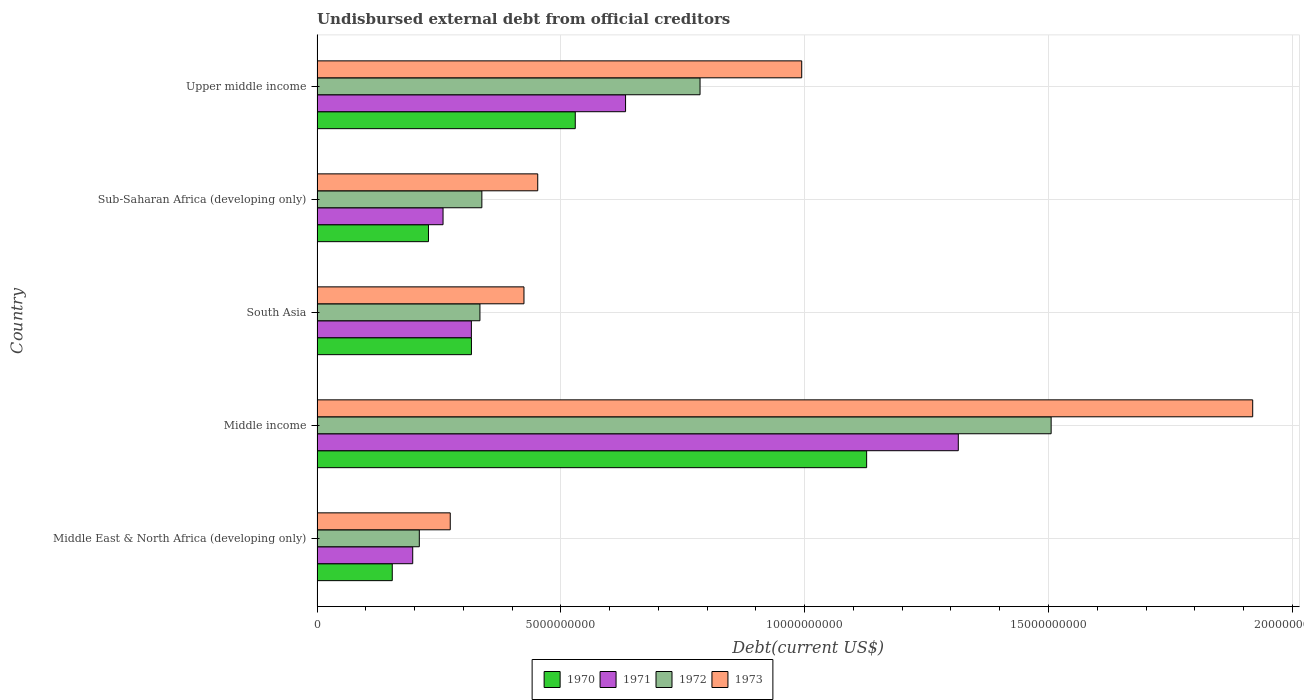How many groups of bars are there?
Provide a short and direct response. 5. Are the number of bars per tick equal to the number of legend labels?
Your answer should be compact. Yes. Are the number of bars on each tick of the Y-axis equal?
Your answer should be very brief. Yes. What is the label of the 3rd group of bars from the top?
Keep it short and to the point. South Asia. What is the total debt in 1973 in Sub-Saharan Africa (developing only)?
Ensure brevity in your answer.  4.53e+09. Across all countries, what is the maximum total debt in 1972?
Give a very brief answer. 1.51e+1. Across all countries, what is the minimum total debt in 1970?
Your answer should be compact. 1.54e+09. In which country was the total debt in 1973 minimum?
Make the answer very short. Middle East & North Africa (developing only). What is the total total debt in 1973 in the graph?
Ensure brevity in your answer.  4.06e+1. What is the difference between the total debt in 1970 in South Asia and that in Upper middle income?
Offer a very short reply. -2.13e+09. What is the difference between the total debt in 1970 in South Asia and the total debt in 1973 in Middle East & North Africa (developing only)?
Keep it short and to the point. 4.35e+08. What is the average total debt in 1972 per country?
Offer a very short reply. 6.35e+09. What is the difference between the total debt in 1972 and total debt in 1971 in Sub-Saharan Africa (developing only)?
Provide a succinct answer. 7.96e+08. In how many countries, is the total debt in 1970 greater than 5000000000 US$?
Make the answer very short. 2. What is the ratio of the total debt in 1970 in Middle East & North Africa (developing only) to that in South Asia?
Keep it short and to the point. 0.49. Is the total debt in 1973 in South Asia less than that in Sub-Saharan Africa (developing only)?
Provide a short and direct response. Yes. What is the difference between the highest and the second highest total debt in 1971?
Make the answer very short. 6.82e+09. What is the difference between the highest and the lowest total debt in 1973?
Ensure brevity in your answer.  1.65e+1. In how many countries, is the total debt in 1970 greater than the average total debt in 1970 taken over all countries?
Your answer should be very brief. 2. What does the 4th bar from the top in Middle income represents?
Provide a succinct answer. 1970. What does the 3rd bar from the bottom in Upper middle income represents?
Offer a terse response. 1972. Are all the bars in the graph horizontal?
Offer a terse response. Yes. What is the difference between two consecutive major ticks on the X-axis?
Give a very brief answer. 5.00e+09. Are the values on the major ticks of X-axis written in scientific E-notation?
Give a very brief answer. No. Does the graph contain any zero values?
Your response must be concise. No. Does the graph contain grids?
Your response must be concise. Yes. Where does the legend appear in the graph?
Your answer should be compact. Bottom center. How many legend labels are there?
Ensure brevity in your answer.  4. What is the title of the graph?
Ensure brevity in your answer.  Undisbursed external debt from official creditors. What is the label or title of the X-axis?
Provide a short and direct response. Debt(current US$). What is the Debt(current US$) in 1970 in Middle East & North Africa (developing only)?
Offer a very short reply. 1.54e+09. What is the Debt(current US$) in 1971 in Middle East & North Africa (developing only)?
Provide a short and direct response. 1.96e+09. What is the Debt(current US$) in 1972 in Middle East & North Africa (developing only)?
Your answer should be very brief. 2.10e+09. What is the Debt(current US$) in 1973 in Middle East & North Africa (developing only)?
Your answer should be compact. 2.73e+09. What is the Debt(current US$) of 1970 in Middle income?
Offer a very short reply. 1.13e+1. What is the Debt(current US$) in 1971 in Middle income?
Keep it short and to the point. 1.32e+1. What is the Debt(current US$) of 1972 in Middle income?
Provide a succinct answer. 1.51e+1. What is the Debt(current US$) of 1973 in Middle income?
Your answer should be compact. 1.92e+1. What is the Debt(current US$) in 1970 in South Asia?
Provide a short and direct response. 3.17e+09. What is the Debt(current US$) of 1971 in South Asia?
Your answer should be very brief. 3.16e+09. What is the Debt(current US$) of 1972 in South Asia?
Keep it short and to the point. 3.34e+09. What is the Debt(current US$) of 1973 in South Asia?
Your response must be concise. 4.24e+09. What is the Debt(current US$) in 1970 in Sub-Saharan Africa (developing only)?
Give a very brief answer. 2.28e+09. What is the Debt(current US$) in 1971 in Sub-Saharan Africa (developing only)?
Your response must be concise. 2.58e+09. What is the Debt(current US$) of 1972 in Sub-Saharan Africa (developing only)?
Provide a succinct answer. 3.38e+09. What is the Debt(current US$) of 1973 in Sub-Saharan Africa (developing only)?
Provide a succinct answer. 4.53e+09. What is the Debt(current US$) of 1970 in Upper middle income?
Ensure brevity in your answer.  5.30e+09. What is the Debt(current US$) of 1971 in Upper middle income?
Provide a short and direct response. 6.33e+09. What is the Debt(current US$) of 1972 in Upper middle income?
Your answer should be very brief. 7.85e+09. What is the Debt(current US$) in 1973 in Upper middle income?
Your response must be concise. 9.94e+09. Across all countries, what is the maximum Debt(current US$) in 1970?
Your answer should be very brief. 1.13e+1. Across all countries, what is the maximum Debt(current US$) in 1971?
Your answer should be compact. 1.32e+1. Across all countries, what is the maximum Debt(current US$) in 1972?
Keep it short and to the point. 1.51e+1. Across all countries, what is the maximum Debt(current US$) of 1973?
Your answer should be very brief. 1.92e+1. Across all countries, what is the minimum Debt(current US$) in 1970?
Offer a terse response. 1.54e+09. Across all countries, what is the minimum Debt(current US$) in 1971?
Provide a succinct answer. 1.96e+09. Across all countries, what is the minimum Debt(current US$) in 1972?
Offer a very short reply. 2.10e+09. Across all countries, what is the minimum Debt(current US$) in 1973?
Give a very brief answer. 2.73e+09. What is the total Debt(current US$) in 1970 in the graph?
Offer a terse response. 2.36e+1. What is the total Debt(current US$) of 1971 in the graph?
Your answer should be very brief. 2.72e+1. What is the total Debt(current US$) in 1972 in the graph?
Offer a very short reply. 3.17e+1. What is the total Debt(current US$) in 1973 in the graph?
Provide a short and direct response. 4.06e+1. What is the difference between the Debt(current US$) of 1970 in Middle East & North Africa (developing only) and that in Middle income?
Provide a short and direct response. -9.73e+09. What is the difference between the Debt(current US$) in 1971 in Middle East & North Africa (developing only) and that in Middle income?
Your answer should be very brief. -1.12e+1. What is the difference between the Debt(current US$) of 1972 in Middle East & North Africa (developing only) and that in Middle income?
Your answer should be compact. -1.30e+1. What is the difference between the Debt(current US$) in 1973 in Middle East & North Africa (developing only) and that in Middle income?
Your response must be concise. -1.65e+1. What is the difference between the Debt(current US$) of 1970 in Middle East & North Africa (developing only) and that in South Asia?
Provide a short and direct response. -1.62e+09. What is the difference between the Debt(current US$) in 1971 in Middle East & North Africa (developing only) and that in South Asia?
Offer a very short reply. -1.20e+09. What is the difference between the Debt(current US$) of 1972 in Middle East & North Africa (developing only) and that in South Asia?
Ensure brevity in your answer.  -1.24e+09. What is the difference between the Debt(current US$) in 1973 in Middle East & North Africa (developing only) and that in South Asia?
Keep it short and to the point. -1.51e+09. What is the difference between the Debt(current US$) of 1970 in Middle East & North Africa (developing only) and that in Sub-Saharan Africa (developing only)?
Keep it short and to the point. -7.42e+08. What is the difference between the Debt(current US$) in 1971 in Middle East & North Africa (developing only) and that in Sub-Saharan Africa (developing only)?
Keep it short and to the point. -6.22e+08. What is the difference between the Debt(current US$) of 1972 in Middle East & North Africa (developing only) and that in Sub-Saharan Africa (developing only)?
Your response must be concise. -1.28e+09. What is the difference between the Debt(current US$) in 1973 in Middle East & North Africa (developing only) and that in Sub-Saharan Africa (developing only)?
Make the answer very short. -1.79e+09. What is the difference between the Debt(current US$) of 1970 in Middle East & North Africa (developing only) and that in Upper middle income?
Offer a terse response. -3.75e+09. What is the difference between the Debt(current US$) of 1971 in Middle East & North Africa (developing only) and that in Upper middle income?
Ensure brevity in your answer.  -4.36e+09. What is the difference between the Debt(current US$) in 1972 in Middle East & North Africa (developing only) and that in Upper middle income?
Offer a very short reply. -5.76e+09. What is the difference between the Debt(current US$) of 1973 in Middle East & North Africa (developing only) and that in Upper middle income?
Provide a succinct answer. -7.21e+09. What is the difference between the Debt(current US$) of 1970 in Middle income and that in South Asia?
Provide a succinct answer. 8.10e+09. What is the difference between the Debt(current US$) in 1971 in Middle income and that in South Asia?
Keep it short and to the point. 9.99e+09. What is the difference between the Debt(current US$) of 1972 in Middle income and that in South Asia?
Ensure brevity in your answer.  1.17e+1. What is the difference between the Debt(current US$) in 1973 in Middle income and that in South Asia?
Give a very brief answer. 1.49e+1. What is the difference between the Debt(current US$) of 1970 in Middle income and that in Sub-Saharan Africa (developing only)?
Keep it short and to the point. 8.99e+09. What is the difference between the Debt(current US$) in 1971 in Middle income and that in Sub-Saharan Africa (developing only)?
Ensure brevity in your answer.  1.06e+1. What is the difference between the Debt(current US$) of 1972 in Middle income and that in Sub-Saharan Africa (developing only)?
Provide a short and direct response. 1.17e+1. What is the difference between the Debt(current US$) in 1973 in Middle income and that in Sub-Saharan Africa (developing only)?
Your answer should be compact. 1.47e+1. What is the difference between the Debt(current US$) of 1970 in Middle income and that in Upper middle income?
Offer a very short reply. 5.98e+09. What is the difference between the Debt(current US$) of 1971 in Middle income and that in Upper middle income?
Give a very brief answer. 6.82e+09. What is the difference between the Debt(current US$) of 1972 in Middle income and that in Upper middle income?
Offer a terse response. 7.20e+09. What is the difference between the Debt(current US$) in 1973 in Middle income and that in Upper middle income?
Provide a succinct answer. 9.25e+09. What is the difference between the Debt(current US$) in 1970 in South Asia and that in Sub-Saharan Africa (developing only)?
Your answer should be very brief. 8.81e+08. What is the difference between the Debt(current US$) in 1971 in South Asia and that in Sub-Saharan Africa (developing only)?
Offer a very short reply. 5.81e+08. What is the difference between the Debt(current US$) of 1972 in South Asia and that in Sub-Saharan Africa (developing only)?
Your answer should be compact. -3.94e+07. What is the difference between the Debt(current US$) of 1973 in South Asia and that in Sub-Saharan Africa (developing only)?
Your answer should be very brief. -2.82e+08. What is the difference between the Debt(current US$) of 1970 in South Asia and that in Upper middle income?
Offer a terse response. -2.13e+09. What is the difference between the Debt(current US$) in 1971 in South Asia and that in Upper middle income?
Give a very brief answer. -3.16e+09. What is the difference between the Debt(current US$) of 1972 in South Asia and that in Upper middle income?
Offer a very short reply. -4.51e+09. What is the difference between the Debt(current US$) of 1973 in South Asia and that in Upper middle income?
Offer a very short reply. -5.70e+09. What is the difference between the Debt(current US$) of 1970 in Sub-Saharan Africa (developing only) and that in Upper middle income?
Offer a terse response. -3.01e+09. What is the difference between the Debt(current US$) in 1971 in Sub-Saharan Africa (developing only) and that in Upper middle income?
Your answer should be compact. -3.74e+09. What is the difference between the Debt(current US$) in 1972 in Sub-Saharan Africa (developing only) and that in Upper middle income?
Make the answer very short. -4.47e+09. What is the difference between the Debt(current US$) of 1973 in Sub-Saharan Africa (developing only) and that in Upper middle income?
Your answer should be very brief. -5.41e+09. What is the difference between the Debt(current US$) of 1970 in Middle East & North Africa (developing only) and the Debt(current US$) of 1971 in Middle income?
Provide a short and direct response. -1.16e+1. What is the difference between the Debt(current US$) of 1970 in Middle East & North Africa (developing only) and the Debt(current US$) of 1972 in Middle income?
Give a very brief answer. -1.35e+1. What is the difference between the Debt(current US$) in 1970 in Middle East & North Africa (developing only) and the Debt(current US$) in 1973 in Middle income?
Make the answer very short. -1.76e+1. What is the difference between the Debt(current US$) in 1971 in Middle East & North Africa (developing only) and the Debt(current US$) in 1972 in Middle income?
Give a very brief answer. -1.31e+1. What is the difference between the Debt(current US$) in 1971 in Middle East & North Africa (developing only) and the Debt(current US$) in 1973 in Middle income?
Provide a succinct answer. -1.72e+1. What is the difference between the Debt(current US$) of 1972 in Middle East & North Africa (developing only) and the Debt(current US$) of 1973 in Middle income?
Make the answer very short. -1.71e+1. What is the difference between the Debt(current US$) in 1970 in Middle East & North Africa (developing only) and the Debt(current US$) in 1971 in South Asia?
Your response must be concise. -1.62e+09. What is the difference between the Debt(current US$) of 1970 in Middle East & North Africa (developing only) and the Debt(current US$) of 1972 in South Asia?
Keep it short and to the point. -1.80e+09. What is the difference between the Debt(current US$) of 1970 in Middle East & North Africa (developing only) and the Debt(current US$) of 1973 in South Asia?
Make the answer very short. -2.70e+09. What is the difference between the Debt(current US$) of 1971 in Middle East & North Africa (developing only) and the Debt(current US$) of 1972 in South Asia?
Ensure brevity in your answer.  -1.38e+09. What is the difference between the Debt(current US$) in 1971 in Middle East & North Africa (developing only) and the Debt(current US$) in 1973 in South Asia?
Ensure brevity in your answer.  -2.28e+09. What is the difference between the Debt(current US$) in 1972 in Middle East & North Africa (developing only) and the Debt(current US$) in 1973 in South Asia?
Ensure brevity in your answer.  -2.15e+09. What is the difference between the Debt(current US$) in 1970 in Middle East & North Africa (developing only) and the Debt(current US$) in 1971 in Sub-Saharan Africa (developing only)?
Ensure brevity in your answer.  -1.04e+09. What is the difference between the Debt(current US$) of 1970 in Middle East & North Africa (developing only) and the Debt(current US$) of 1972 in Sub-Saharan Africa (developing only)?
Provide a short and direct response. -1.84e+09. What is the difference between the Debt(current US$) of 1970 in Middle East & North Africa (developing only) and the Debt(current US$) of 1973 in Sub-Saharan Africa (developing only)?
Your response must be concise. -2.98e+09. What is the difference between the Debt(current US$) of 1971 in Middle East & North Africa (developing only) and the Debt(current US$) of 1972 in Sub-Saharan Africa (developing only)?
Ensure brevity in your answer.  -1.42e+09. What is the difference between the Debt(current US$) of 1971 in Middle East & North Africa (developing only) and the Debt(current US$) of 1973 in Sub-Saharan Africa (developing only)?
Ensure brevity in your answer.  -2.56e+09. What is the difference between the Debt(current US$) in 1972 in Middle East & North Africa (developing only) and the Debt(current US$) in 1973 in Sub-Saharan Africa (developing only)?
Give a very brief answer. -2.43e+09. What is the difference between the Debt(current US$) in 1970 in Middle East & North Africa (developing only) and the Debt(current US$) in 1971 in Upper middle income?
Give a very brief answer. -4.78e+09. What is the difference between the Debt(current US$) of 1970 in Middle East & North Africa (developing only) and the Debt(current US$) of 1972 in Upper middle income?
Make the answer very short. -6.31e+09. What is the difference between the Debt(current US$) of 1970 in Middle East & North Africa (developing only) and the Debt(current US$) of 1973 in Upper middle income?
Your response must be concise. -8.40e+09. What is the difference between the Debt(current US$) of 1971 in Middle East & North Africa (developing only) and the Debt(current US$) of 1972 in Upper middle income?
Give a very brief answer. -5.89e+09. What is the difference between the Debt(current US$) of 1971 in Middle East & North Africa (developing only) and the Debt(current US$) of 1973 in Upper middle income?
Provide a short and direct response. -7.98e+09. What is the difference between the Debt(current US$) of 1972 in Middle East & North Africa (developing only) and the Debt(current US$) of 1973 in Upper middle income?
Make the answer very short. -7.84e+09. What is the difference between the Debt(current US$) of 1970 in Middle income and the Debt(current US$) of 1971 in South Asia?
Give a very brief answer. 8.11e+09. What is the difference between the Debt(current US$) of 1970 in Middle income and the Debt(current US$) of 1972 in South Asia?
Your answer should be very brief. 7.93e+09. What is the difference between the Debt(current US$) in 1970 in Middle income and the Debt(current US$) in 1973 in South Asia?
Give a very brief answer. 7.03e+09. What is the difference between the Debt(current US$) in 1971 in Middle income and the Debt(current US$) in 1972 in South Asia?
Give a very brief answer. 9.81e+09. What is the difference between the Debt(current US$) of 1971 in Middle income and the Debt(current US$) of 1973 in South Asia?
Offer a terse response. 8.91e+09. What is the difference between the Debt(current US$) of 1972 in Middle income and the Debt(current US$) of 1973 in South Asia?
Provide a succinct answer. 1.08e+1. What is the difference between the Debt(current US$) of 1970 in Middle income and the Debt(current US$) of 1971 in Sub-Saharan Africa (developing only)?
Offer a terse response. 8.69e+09. What is the difference between the Debt(current US$) of 1970 in Middle income and the Debt(current US$) of 1972 in Sub-Saharan Africa (developing only)?
Provide a short and direct response. 7.89e+09. What is the difference between the Debt(current US$) in 1970 in Middle income and the Debt(current US$) in 1973 in Sub-Saharan Africa (developing only)?
Make the answer very short. 6.75e+09. What is the difference between the Debt(current US$) of 1971 in Middle income and the Debt(current US$) of 1972 in Sub-Saharan Africa (developing only)?
Your answer should be very brief. 9.77e+09. What is the difference between the Debt(current US$) in 1971 in Middle income and the Debt(current US$) in 1973 in Sub-Saharan Africa (developing only)?
Make the answer very short. 8.62e+09. What is the difference between the Debt(current US$) of 1972 in Middle income and the Debt(current US$) of 1973 in Sub-Saharan Africa (developing only)?
Ensure brevity in your answer.  1.05e+1. What is the difference between the Debt(current US$) in 1970 in Middle income and the Debt(current US$) in 1971 in Upper middle income?
Ensure brevity in your answer.  4.94e+09. What is the difference between the Debt(current US$) of 1970 in Middle income and the Debt(current US$) of 1972 in Upper middle income?
Offer a terse response. 3.42e+09. What is the difference between the Debt(current US$) of 1970 in Middle income and the Debt(current US$) of 1973 in Upper middle income?
Ensure brevity in your answer.  1.33e+09. What is the difference between the Debt(current US$) of 1971 in Middle income and the Debt(current US$) of 1972 in Upper middle income?
Provide a short and direct response. 5.30e+09. What is the difference between the Debt(current US$) in 1971 in Middle income and the Debt(current US$) in 1973 in Upper middle income?
Keep it short and to the point. 3.21e+09. What is the difference between the Debt(current US$) of 1972 in Middle income and the Debt(current US$) of 1973 in Upper middle income?
Offer a very short reply. 5.12e+09. What is the difference between the Debt(current US$) in 1970 in South Asia and the Debt(current US$) in 1971 in Sub-Saharan Africa (developing only)?
Make the answer very short. 5.82e+08. What is the difference between the Debt(current US$) of 1970 in South Asia and the Debt(current US$) of 1972 in Sub-Saharan Africa (developing only)?
Your response must be concise. -2.14e+08. What is the difference between the Debt(current US$) of 1970 in South Asia and the Debt(current US$) of 1973 in Sub-Saharan Africa (developing only)?
Offer a very short reply. -1.36e+09. What is the difference between the Debt(current US$) of 1971 in South Asia and the Debt(current US$) of 1972 in Sub-Saharan Africa (developing only)?
Provide a succinct answer. -2.15e+08. What is the difference between the Debt(current US$) of 1971 in South Asia and the Debt(current US$) of 1973 in Sub-Saharan Africa (developing only)?
Your answer should be compact. -1.36e+09. What is the difference between the Debt(current US$) of 1972 in South Asia and the Debt(current US$) of 1973 in Sub-Saharan Africa (developing only)?
Provide a succinct answer. -1.19e+09. What is the difference between the Debt(current US$) of 1970 in South Asia and the Debt(current US$) of 1971 in Upper middle income?
Make the answer very short. -3.16e+09. What is the difference between the Debt(current US$) in 1970 in South Asia and the Debt(current US$) in 1972 in Upper middle income?
Give a very brief answer. -4.69e+09. What is the difference between the Debt(current US$) in 1970 in South Asia and the Debt(current US$) in 1973 in Upper middle income?
Offer a very short reply. -6.77e+09. What is the difference between the Debt(current US$) of 1971 in South Asia and the Debt(current US$) of 1972 in Upper middle income?
Give a very brief answer. -4.69e+09. What is the difference between the Debt(current US$) of 1971 in South Asia and the Debt(current US$) of 1973 in Upper middle income?
Provide a short and direct response. -6.77e+09. What is the difference between the Debt(current US$) of 1972 in South Asia and the Debt(current US$) of 1973 in Upper middle income?
Your answer should be compact. -6.60e+09. What is the difference between the Debt(current US$) of 1970 in Sub-Saharan Africa (developing only) and the Debt(current US$) of 1971 in Upper middle income?
Your answer should be very brief. -4.04e+09. What is the difference between the Debt(current US$) in 1970 in Sub-Saharan Africa (developing only) and the Debt(current US$) in 1972 in Upper middle income?
Your answer should be compact. -5.57e+09. What is the difference between the Debt(current US$) of 1970 in Sub-Saharan Africa (developing only) and the Debt(current US$) of 1973 in Upper middle income?
Offer a very short reply. -7.65e+09. What is the difference between the Debt(current US$) in 1971 in Sub-Saharan Africa (developing only) and the Debt(current US$) in 1972 in Upper middle income?
Provide a short and direct response. -5.27e+09. What is the difference between the Debt(current US$) in 1971 in Sub-Saharan Africa (developing only) and the Debt(current US$) in 1973 in Upper middle income?
Offer a very short reply. -7.36e+09. What is the difference between the Debt(current US$) in 1972 in Sub-Saharan Africa (developing only) and the Debt(current US$) in 1973 in Upper middle income?
Offer a very short reply. -6.56e+09. What is the average Debt(current US$) in 1970 per country?
Provide a short and direct response. 4.71e+09. What is the average Debt(current US$) in 1971 per country?
Give a very brief answer. 5.44e+09. What is the average Debt(current US$) in 1972 per country?
Make the answer very short. 6.35e+09. What is the average Debt(current US$) in 1973 per country?
Your answer should be compact. 8.13e+09. What is the difference between the Debt(current US$) in 1970 and Debt(current US$) in 1971 in Middle East & North Africa (developing only)?
Your answer should be compact. -4.19e+08. What is the difference between the Debt(current US$) of 1970 and Debt(current US$) of 1972 in Middle East & North Africa (developing only)?
Offer a terse response. -5.55e+08. What is the difference between the Debt(current US$) in 1970 and Debt(current US$) in 1973 in Middle East & North Africa (developing only)?
Provide a succinct answer. -1.19e+09. What is the difference between the Debt(current US$) in 1971 and Debt(current US$) in 1972 in Middle East & North Africa (developing only)?
Your response must be concise. -1.35e+08. What is the difference between the Debt(current US$) of 1971 and Debt(current US$) of 1973 in Middle East & North Africa (developing only)?
Offer a very short reply. -7.70e+08. What is the difference between the Debt(current US$) of 1972 and Debt(current US$) of 1973 in Middle East & North Africa (developing only)?
Offer a very short reply. -6.34e+08. What is the difference between the Debt(current US$) in 1970 and Debt(current US$) in 1971 in Middle income?
Keep it short and to the point. -1.88e+09. What is the difference between the Debt(current US$) of 1970 and Debt(current US$) of 1972 in Middle income?
Your response must be concise. -3.78e+09. What is the difference between the Debt(current US$) in 1970 and Debt(current US$) in 1973 in Middle income?
Ensure brevity in your answer.  -7.92e+09. What is the difference between the Debt(current US$) of 1971 and Debt(current US$) of 1972 in Middle income?
Provide a succinct answer. -1.90e+09. What is the difference between the Debt(current US$) of 1971 and Debt(current US$) of 1973 in Middle income?
Keep it short and to the point. -6.04e+09. What is the difference between the Debt(current US$) of 1972 and Debt(current US$) of 1973 in Middle income?
Make the answer very short. -4.13e+09. What is the difference between the Debt(current US$) in 1970 and Debt(current US$) in 1971 in South Asia?
Offer a very short reply. 1.31e+06. What is the difference between the Debt(current US$) in 1970 and Debt(current US$) in 1972 in South Asia?
Your response must be concise. -1.74e+08. What is the difference between the Debt(current US$) of 1970 and Debt(current US$) of 1973 in South Asia?
Your answer should be compact. -1.08e+09. What is the difference between the Debt(current US$) in 1971 and Debt(current US$) in 1972 in South Asia?
Your answer should be very brief. -1.76e+08. What is the difference between the Debt(current US$) in 1971 and Debt(current US$) in 1973 in South Asia?
Your answer should be very brief. -1.08e+09. What is the difference between the Debt(current US$) of 1972 and Debt(current US$) of 1973 in South Asia?
Your answer should be very brief. -9.03e+08. What is the difference between the Debt(current US$) in 1970 and Debt(current US$) in 1971 in Sub-Saharan Africa (developing only)?
Ensure brevity in your answer.  -2.99e+08. What is the difference between the Debt(current US$) in 1970 and Debt(current US$) in 1972 in Sub-Saharan Africa (developing only)?
Your answer should be compact. -1.09e+09. What is the difference between the Debt(current US$) in 1970 and Debt(current US$) in 1973 in Sub-Saharan Africa (developing only)?
Your response must be concise. -2.24e+09. What is the difference between the Debt(current US$) of 1971 and Debt(current US$) of 1972 in Sub-Saharan Africa (developing only)?
Make the answer very short. -7.96e+08. What is the difference between the Debt(current US$) in 1971 and Debt(current US$) in 1973 in Sub-Saharan Africa (developing only)?
Your answer should be very brief. -1.94e+09. What is the difference between the Debt(current US$) in 1972 and Debt(current US$) in 1973 in Sub-Saharan Africa (developing only)?
Your answer should be very brief. -1.15e+09. What is the difference between the Debt(current US$) in 1970 and Debt(current US$) in 1971 in Upper middle income?
Provide a short and direct response. -1.03e+09. What is the difference between the Debt(current US$) of 1970 and Debt(current US$) of 1972 in Upper middle income?
Give a very brief answer. -2.56e+09. What is the difference between the Debt(current US$) in 1970 and Debt(current US$) in 1973 in Upper middle income?
Keep it short and to the point. -4.64e+09. What is the difference between the Debt(current US$) of 1971 and Debt(current US$) of 1972 in Upper middle income?
Provide a short and direct response. -1.53e+09. What is the difference between the Debt(current US$) in 1971 and Debt(current US$) in 1973 in Upper middle income?
Keep it short and to the point. -3.61e+09. What is the difference between the Debt(current US$) of 1972 and Debt(current US$) of 1973 in Upper middle income?
Ensure brevity in your answer.  -2.08e+09. What is the ratio of the Debt(current US$) of 1970 in Middle East & North Africa (developing only) to that in Middle income?
Your answer should be compact. 0.14. What is the ratio of the Debt(current US$) in 1971 in Middle East & North Africa (developing only) to that in Middle income?
Provide a succinct answer. 0.15. What is the ratio of the Debt(current US$) in 1972 in Middle East & North Africa (developing only) to that in Middle income?
Your response must be concise. 0.14. What is the ratio of the Debt(current US$) of 1973 in Middle East & North Africa (developing only) to that in Middle income?
Provide a succinct answer. 0.14. What is the ratio of the Debt(current US$) in 1970 in Middle East & North Africa (developing only) to that in South Asia?
Offer a very short reply. 0.49. What is the ratio of the Debt(current US$) in 1971 in Middle East & North Africa (developing only) to that in South Asia?
Your answer should be very brief. 0.62. What is the ratio of the Debt(current US$) in 1972 in Middle East & North Africa (developing only) to that in South Asia?
Offer a terse response. 0.63. What is the ratio of the Debt(current US$) in 1973 in Middle East & North Africa (developing only) to that in South Asia?
Offer a terse response. 0.64. What is the ratio of the Debt(current US$) of 1970 in Middle East & North Africa (developing only) to that in Sub-Saharan Africa (developing only)?
Ensure brevity in your answer.  0.68. What is the ratio of the Debt(current US$) of 1971 in Middle East & North Africa (developing only) to that in Sub-Saharan Africa (developing only)?
Ensure brevity in your answer.  0.76. What is the ratio of the Debt(current US$) of 1972 in Middle East & North Africa (developing only) to that in Sub-Saharan Africa (developing only)?
Your response must be concise. 0.62. What is the ratio of the Debt(current US$) in 1973 in Middle East & North Africa (developing only) to that in Sub-Saharan Africa (developing only)?
Your answer should be compact. 0.6. What is the ratio of the Debt(current US$) of 1970 in Middle East & North Africa (developing only) to that in Upper middle income?
Offer a very short reply. 0.29. What is the ratio of the Debt(current US$) in 1971 in Middle East & North Africa (developing only) to that in Upper middle income?
Ensure brevity in your answer.  0.31. What is the ratio of the Debt(current US$) in 1972 in Middle East & North Africa (developing only) to that in Upper middle income?
Offer a very short reply. 0.27. What is the ratio of the Debt(current US$) of 1973 in Middle East & North Africa (developing only) to that in Upper middle income?
Give a very brief answer. 0.27. What is the ratio of the Debt(current US$) in 1970 in Middle income to that in South Asia?
Ensure brevity in your answer.  3.56. What is the ratio of the Debt(current US$) in 1971 in Middle income to that in South Asia?
Your response must be concise. 4.16. What is the ratio of the Debt(current US$) in 1972 in Middle income to that in South Asia?
Ensure brevity in your answer.  4.51. What is the ratio of the Debt(current US$) in 1973 in Middle income to that in South Asia?
Offer a terse response. 4.52. What is the ratio of the Debt(current US$) of 1970 in Middle income to that in Sub-Saharan Africa (developing only)?
Provide a short and direct response. 4.93. What is the ratio of the Debt(current US$) of 1971 in Middle income to that in Sub-Saharan Africa (developing only)?
Your answer should be compact. 5.09. What is the ratio of the Debt(current US$) in 1972 in Middle income to that in Sub-Saharan Africa (developing only)?
Give a very brief answer. 4.45. What is the ratio of the Debt(current US$) in 1973 in Middle income to that in Sub-Saharan Africa (developing only)?
Your answer should be compact. 4.24. What is the ratio of the Debt(current US$) in 1970 in Middle income to that in Upper middle income?
Offer a terse response. 2.13. What is the ratio of the Debt(current US$) in 1971 in Middle income to that in Upper middle income?
Keep it short and to the point. 2.08. What is the ratio of the Debt(current US$) of 1972 in Middle income to that in Upper middle income?
Offer a terse response. 1.92. What is the ratio of the Debt(current US$) in 1973 in Middle income to that in Upper middle income?
Keep it short and to the point. 1.93. What is the ratio of the Debt(current US$) in 1970 in South Asia to that in Sub-Saharan Africa (developing only)?
Give a very brief answer. 1.39. What is the ratio of the Debt(current US$) in 1971 in South Asia to that in Sub-Saharan Africa (developing only)?
Provide a succinct answer. 1.22. What is the ratio of the Debt(current US$) of 1972 in South Asia to that in Sub-Saharan Africa (developing only)?
Ensure brevity in your answer.  0.99. What is the ratio of the Debt(current US$) of 1973 in South Asia to that in Sub-Saharan Africa (developing only)?
Your response must be concise. 0.94. What is the ratio of the Debt(current US$) of 1970 in South Asia to that in Upper middle income?
Keep it short and to the point. 0.6. What is the ratio of the Debt(current US$) in 1971 in South Asia to that in Upper middle income?
Give a very brief answer. 0.5. What is the ratio of the Debt(current US$) in 1972 in South Asia to that in Upper middle income?
Ensure brevity in your answer.  0.43. What is the ratio of the Debt(current US$) of 1973 in South Asia to that in Upper middle income?
Your answer should be compact. 0.43. What is the ratio of the Debt(current US$) in 1970 in Sub-Saharan Africa (developing only) to that in Upper middle income?
Ensure brevity in your answer.  0.43. What is the ratio of the Debt(current US$) of 1971 in Sub-Saharan Africa (developing only) to that in Upper middle income?
Provide a short and direct response. 0.41. What is the ratio of the Debt(current US$) in 1972 in Sub-Saharan Africa (developing only) to that in Upper middle income?
Ensure brevity in your answer.  0.43. What is the ratio of the Debt(current US$) in 1973 in Sub-Saharan Africa (developing only) to that in Upper middle income?
Your answer should be compact. 0.46. What is the difference between the highest and the second highest Debt(current US$) in 1970?
Your response must be concise. 5.98e+09. What is the difference between the highest and the second highest Debt(current US$) in 1971?
Your answer should be very brief. 6.82e+09. What is the difference between the highest and the second highest Debt(current US$) of 1972?
Offer a very short reply. 7.20e+09. What is the difference between the highest and the second highest Debt(current US$) in 1973?
Provide a succinct answer. 9.25e+09. What is the difference between the highest and the lowest Debt(current US$) in 1970?
Keep it short and to the point. 9.73e+09. What is the difference between the highest and the lowest Debt(current US$) in 1971?
Keep it short and to the point. 1.12e+1. What is the difference between the highest and the lowest Debt(current US$) in 1972?
Ensure brevity in your answer.  1.30e+1. What is the difference between the highest and the lowest Debt(current US$) in 1973?
Your answer should be compact. 1.65e+1. 